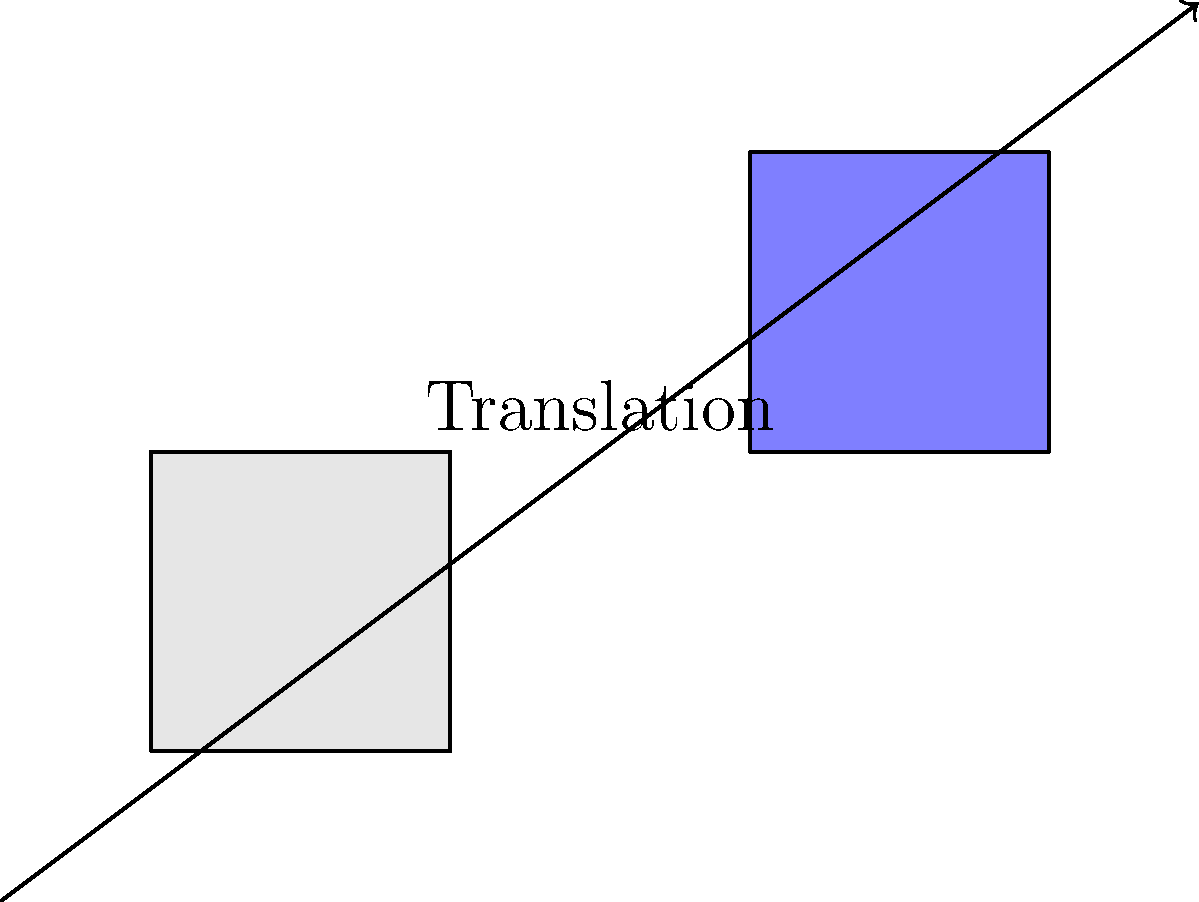In traditional Swiss embroidery, a square pattern is often used as a basic element. If this square pattern is translated 2 units to the right and 1 unit up, what would be the coordinates of the top-right corner of the translated square, given that the original square's top-right corner was at (1,1)? To solve this problem, we need to follow these steps:

1. Identify the original coordinates:
   The top-right corner of the original square is at (1,1).

2. Understand the translation:
   The pattern is translated 2 units to the right (positive x-direction) and 1 unit up (positive y-direction).

3. Apply the translation:
   - For the x-coordinate: $1 + 2 = 3$
   - For the y-coordinate: $1 + 1 = 2$

4. Combine the new coordinates:
   The new top-right corner will be at (3,2).

This translation can be represented mathematically as:

$$(x, y) \rightarrow (x+2, y+1)$$

where $(x,y)$ are the coordinates of any point in the original square.
Answer: (3,2) 